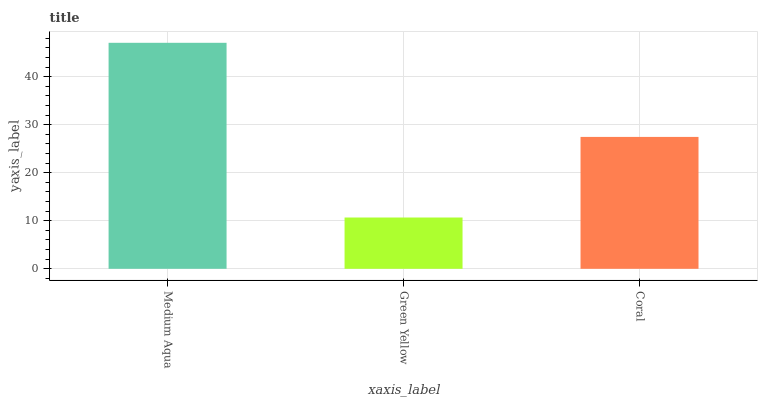Is Green Yellow the minimum?
Answer yes or no. Yes. Is Medium Aqua the maximum?
Answer yes or no. Yes. Is Coral the minimum?
Answer yes or no. No. Is Coral the maximum?
Answer yes or no. No. Is Coral greater than Green Yellow?
Answer yes or no. Yes. Is Green Yellow less than Coral?
Answer yes or no. Yes. Is Green Yellow greater than Coral?
Answer yes or no. No. Is Coral less than Green Yellow?
Answer yes or no. No. Is Coral the high median?
Answer yes or no. Yes. Is Coral the low median?
Answer yes or no. Yes. Is Green Yellow the high median?
Answer yes or no. No. Is Medium Aqua the low median?
Answer yes or no. No. 